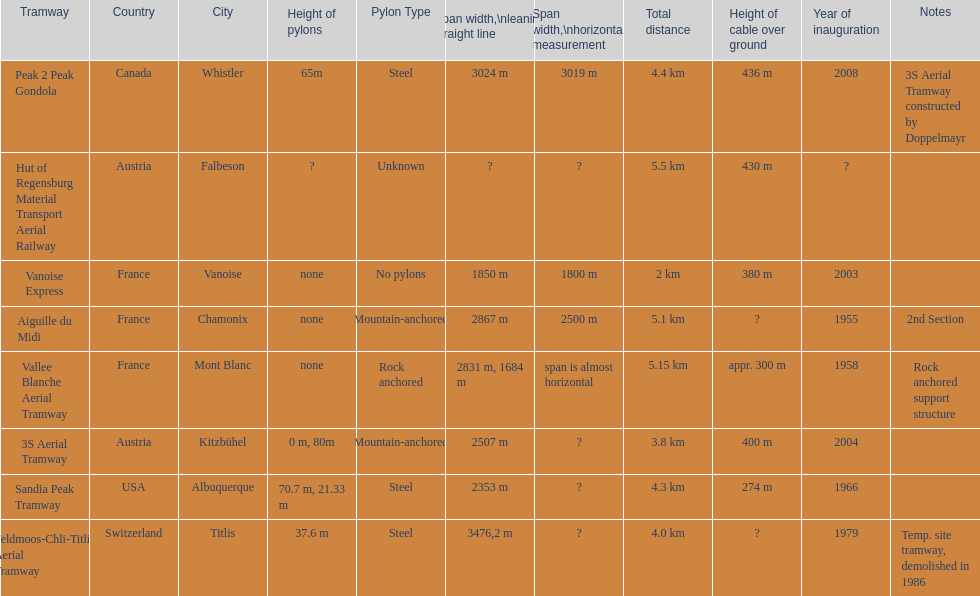Was the sandia peak tramway innagurate before or after the 3s aerial tramway? Before. 